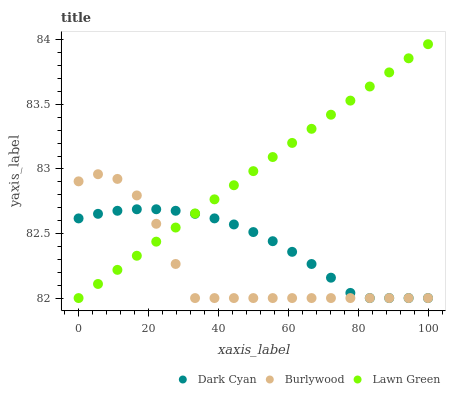Does Burlywood have the minimum area under the curve?
Answer yes or no. Yes. Does Lawn Green have the maximum area under the curve?
Answer yes or no. Yes. Does Lawn Green have the minimum area under the curve?
Answer yes or no. No. Does Burlywood have the maximum area under the curve?
Answer yes or no. No. Is Lawn Green the smoothest?
Answer yes or no. Yes. Is Burlywood the roughest?
Answer yes or no. Yes. Is Burlywood the smoothest?
Answer yes or no. No. Is Lawn Green the roughest?
Answer yes or no. No. Does Dark Cyan have the lowest value?
Answer yes or no. Yes. Does Lawn Green have the highest value?
Answer yes or no. Yes. Does Burlywood have the highest value?
Answer yes or no. No. Does Burlywood intersect Dark Cyan?
Answer yes or no. Yes. Is Burlywood less than Dark Cyan?
Answer yes or no. No. Is Burlywood greater than Dark Cyan?
Answer yes or no. No. 